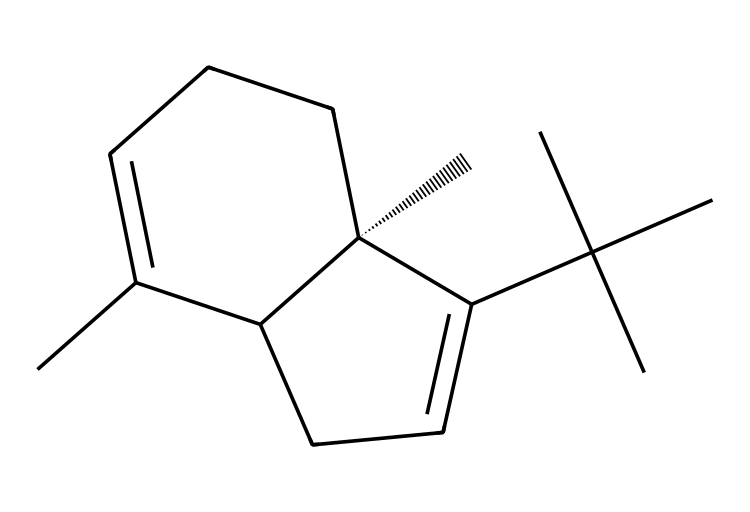What is the total number of carbon atoms in beta-caryophyllene? By analyzing the SMILES notation, we can count the number of "C" characters, which represent carbon atoms. The total count of "C" in the provided SMILES is 15.
Answer: 15 How many double bonds are present in the structure? In the SMILES representation, double bonds are typically indicated by specific connections between carbon atoms that are not directly bonded with other atoms. Counting the "C=C" instances reveals 1 double bond in beta-caryophyllene.
Answer: 1 What kind of structure does beta-caryophyllene have? Beta-caryophyllene has a cycloalkene structure due to the presence of a ring and a double bond within that structure. It is characterized as a bicyclic compound as it has two interconnected rings.
Answer: bicyclic Is beta-caryophyllene chiral? The presence of a stereocenter is indicated in the SMILES with the "@", confirming chirality in this molecule. The configuration around the indicated carbon creates non-superimposable mirror images, confirming its chiral nature.
Answer: yes What type of functional groups are present in the structure? This compound does not possess typical functional groups like alcohols or ketones. Instead, it features only hydrocarbons (due to its terpene nature), primarily in the form of rings and double bonds, hence it is largely categorized as a hydrocarbon structure.
Answer: hydrocarbon 